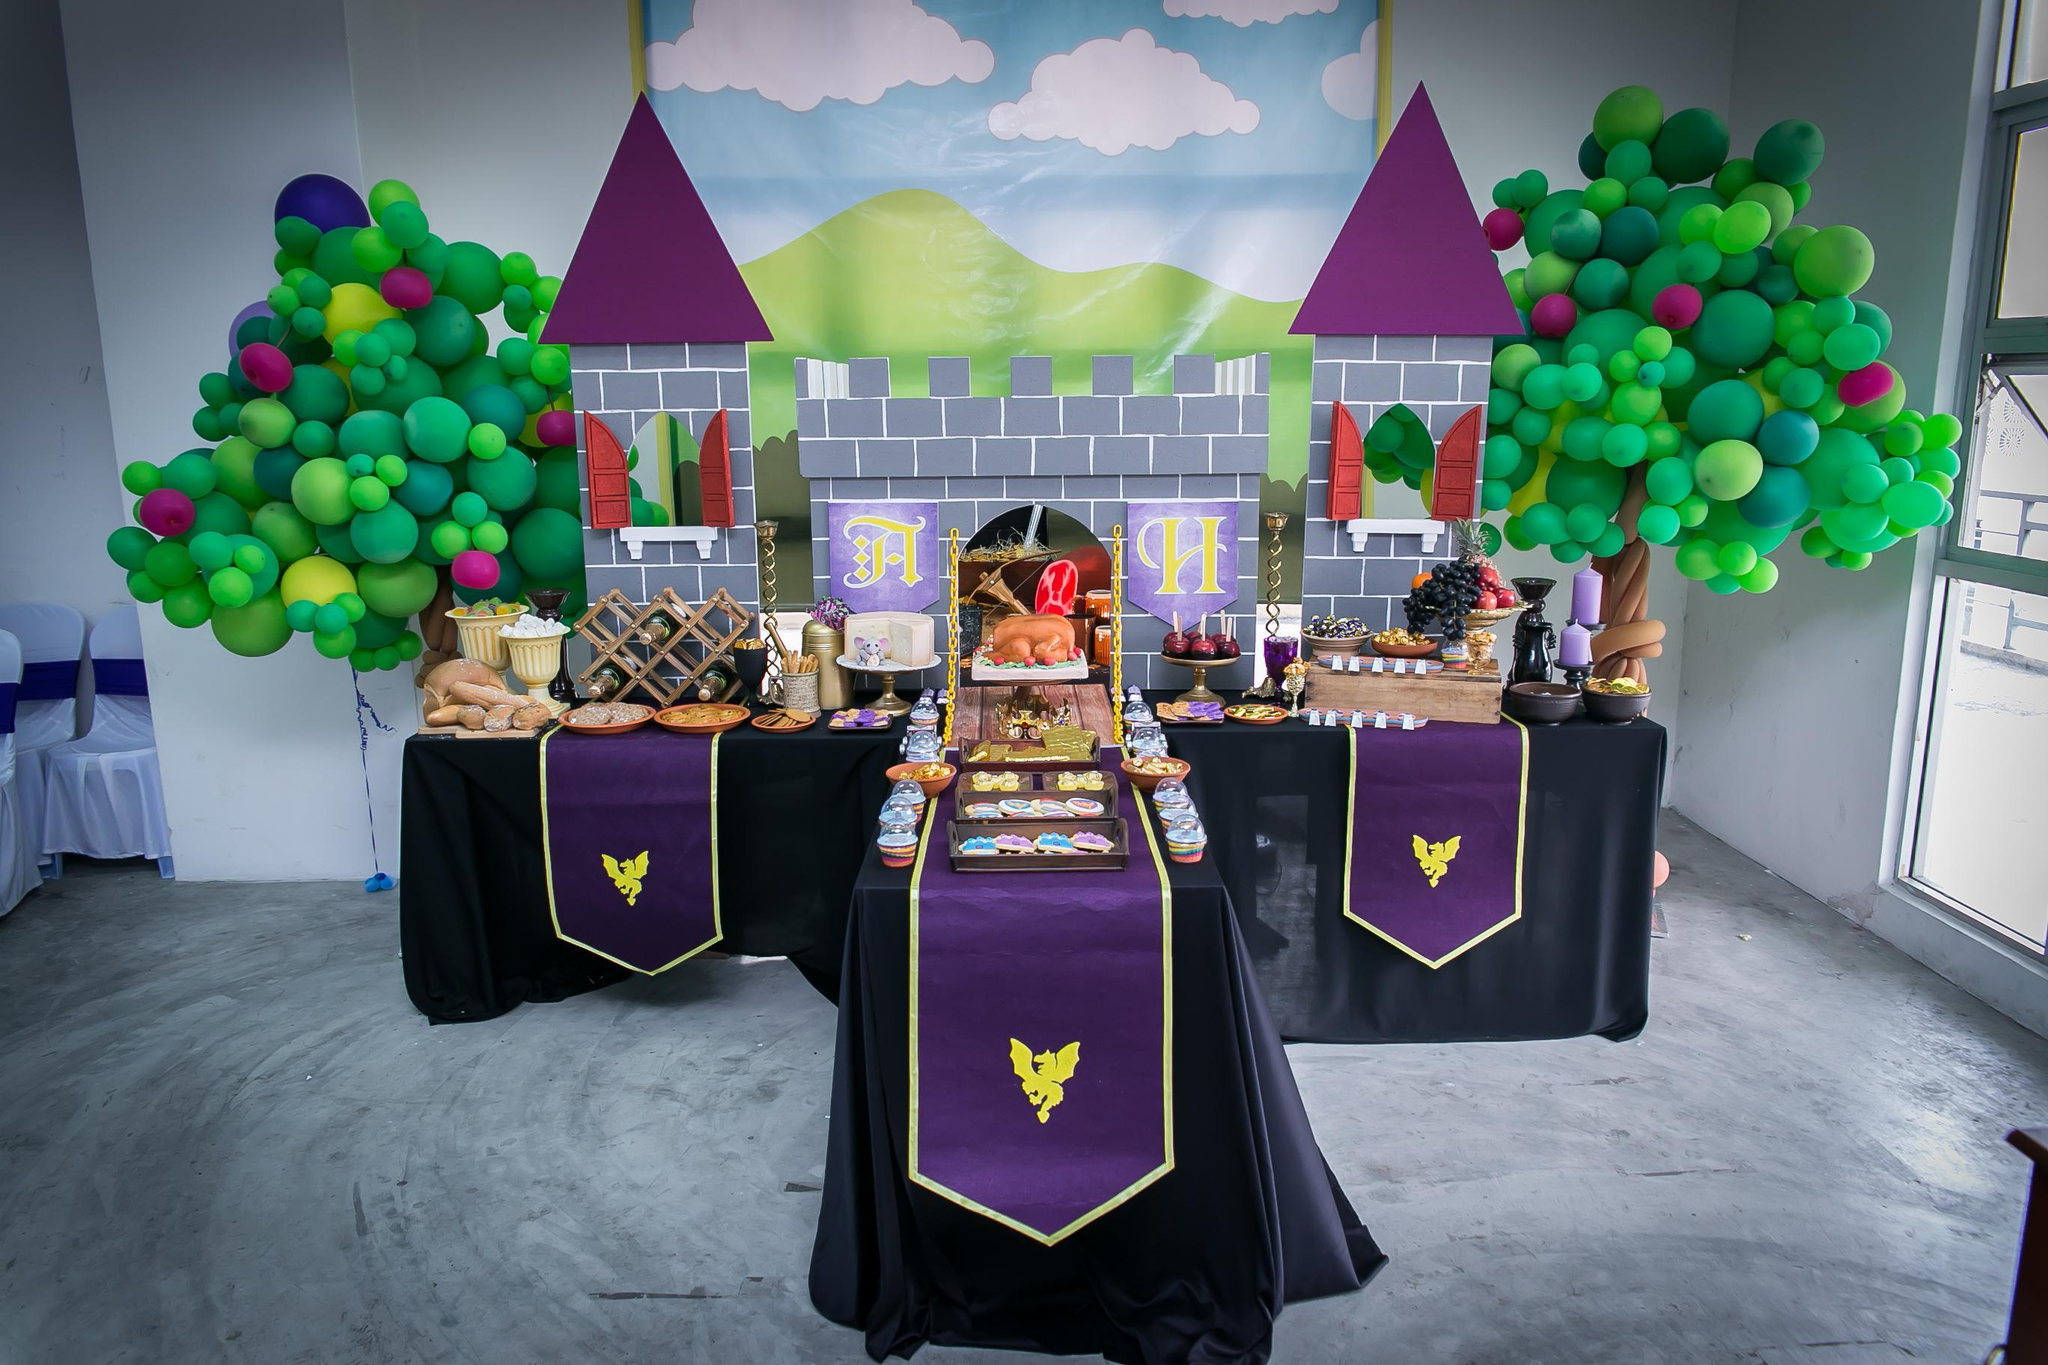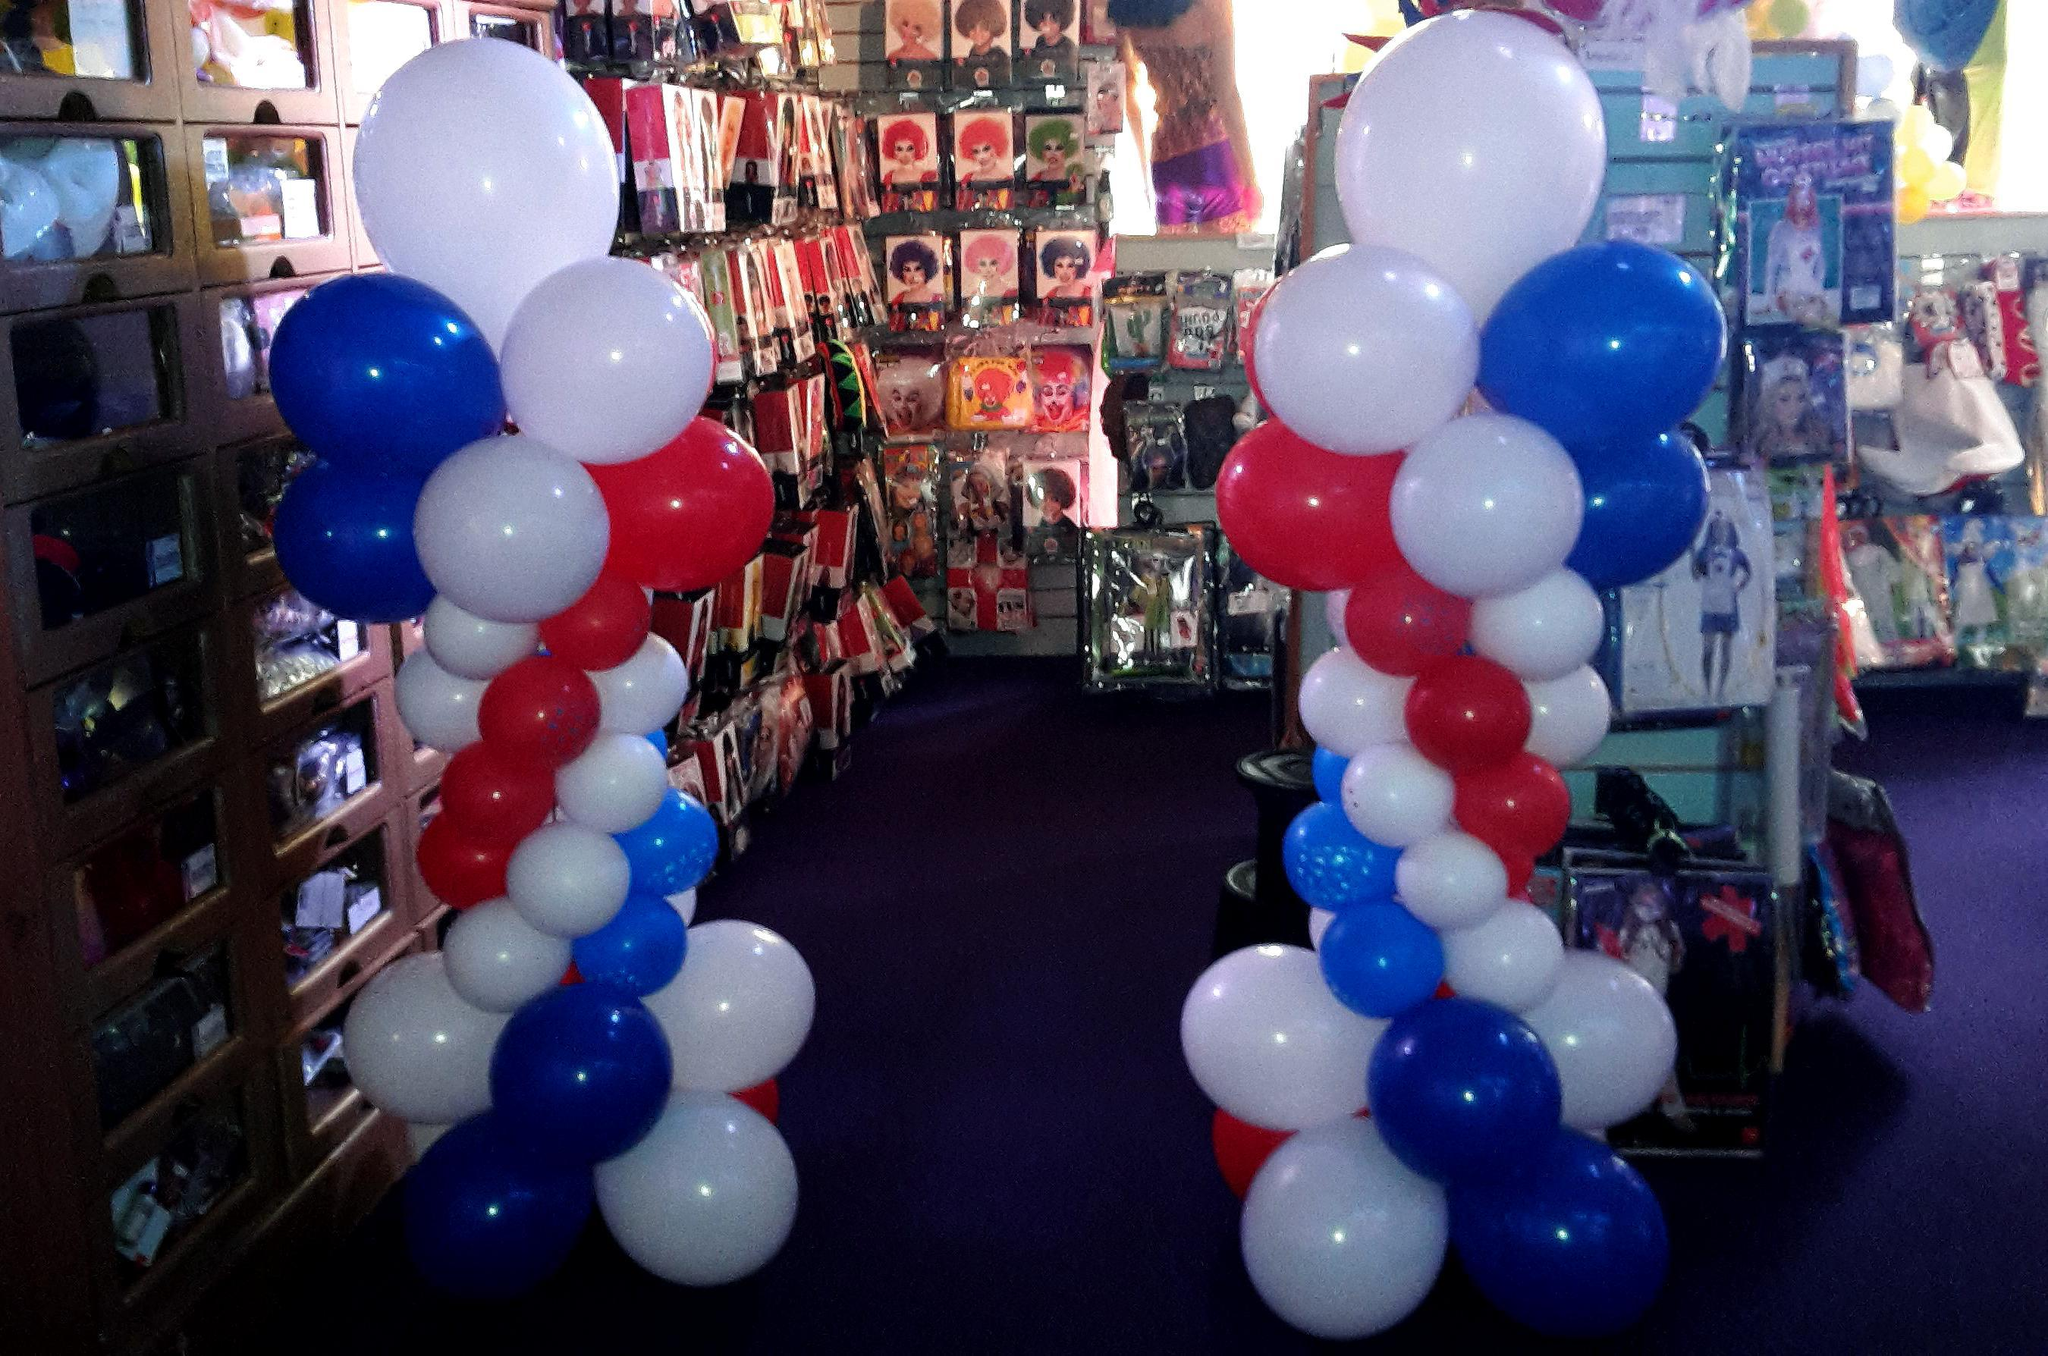The first image is the image on the left, the second image is the image on the right. For the images displayed, is the sentence "There are at least 15 balloons inside a party shop or ballon store." factually correct? Answer yes or no. Yes. The first image is the image on the left, the second image is the image on the right. For the images shown, is this caption "There are solid red balloons in the right image, and green balloons in the left." true? Answer yes or no. Yes. 